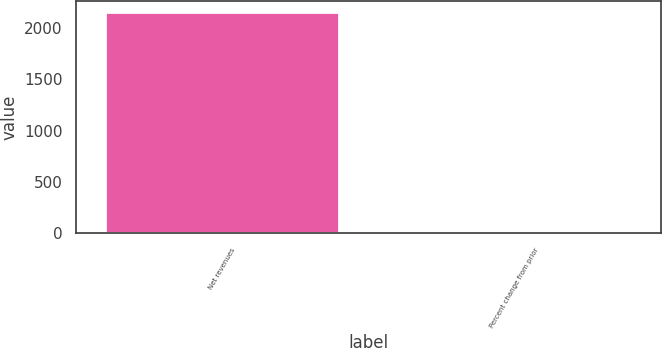Convert chart to OTSL. <chart><loc_0><loc_0><loc_500><loc_500><bar_chart><fcel>Net revenues<fcel>Percent change from prior<nl><fcel>2150<fcel>1<nl></chart> 